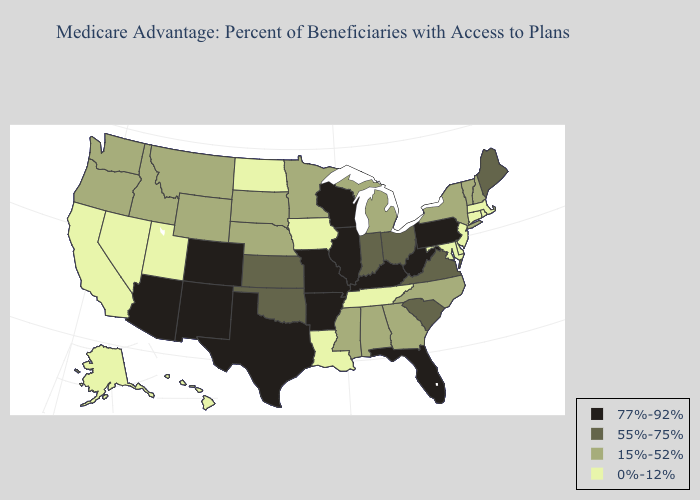What is the highest value in the MidWest ?
Answer briefly. 77%-92%. Does New York have the highest value in the Northeast?
Keep it brief. No. Does North Carolina have the highest value in the South?
Give a very brief answer. No. Name the states that have a value in the range 77%-92%?
Keep it brief. Colorado, Florida, Illinois, Kentucky, Missouri, New Mexico, Pennsylvania, Texas, Wisconsin, West Virginia, Arkansas, Arizona. What is the highest value in states that border Wisconsin?
Be succinct. 77%-92%. Does the first symbol in the legend represent the smallest category?
Be succinct. No. Which states have the lowest value in the USA?
Give a very brief answer. California, Connecticut, Delaware, Hawaii, Iowa, Louisiana, Massachusetts, Maryland, North Dakota, New Jersey, Nevada, Rhode Island, Alaska, Tennessee, Utah. Does Virginia have a lower value than Kentucky?
Quick response, please. Yes. What is the lowest value in states that border Delaware?
Keep it brief. 0%-12%. Which states have the lowest value in the USA?
Give a very brief answer. California, Connecticut, Delaware, Hawaii, Iowa, Louisiana, Massachusetts, Maryland, North Dakota, New Jersey, Nevada, Rhode Island, Alaska, Tennessee, Utah. Name the states that have a value in the range 15%-52%?
Give a very brief answer. Georgia, Idaho, Michigan, Minnesota, Mississippi, Montana, North Carolina, Nebraska, New Hampshire, New York, Oregon, South Dakota, Vermont, Washington, Wyoming, Alabama. Does North Dakota have a lower value than Delaware?
Be succinct. No. What is the value of Wyoming?
Quick response, please. 15%-52%. Does the first symbol in the legend represent the smallest category?
Keep it brief. No. Name the states that have a value in the range 55%-75%?
Be succinct. Indiana, Kansas, Maine, Ohio, Oklahoma, South Carolina, Virginia. 